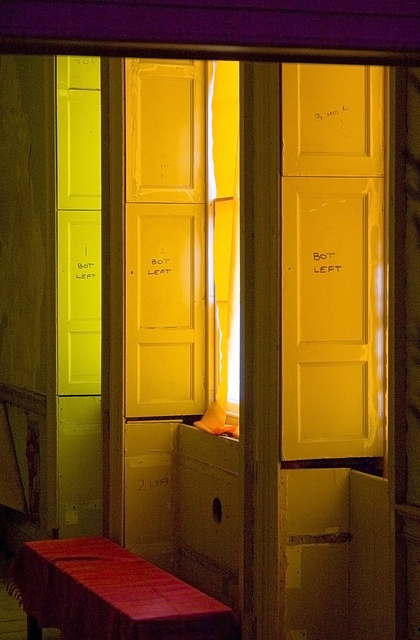Please identify all text content in this image. BOT LEFT L BoTT LEFT BOT 